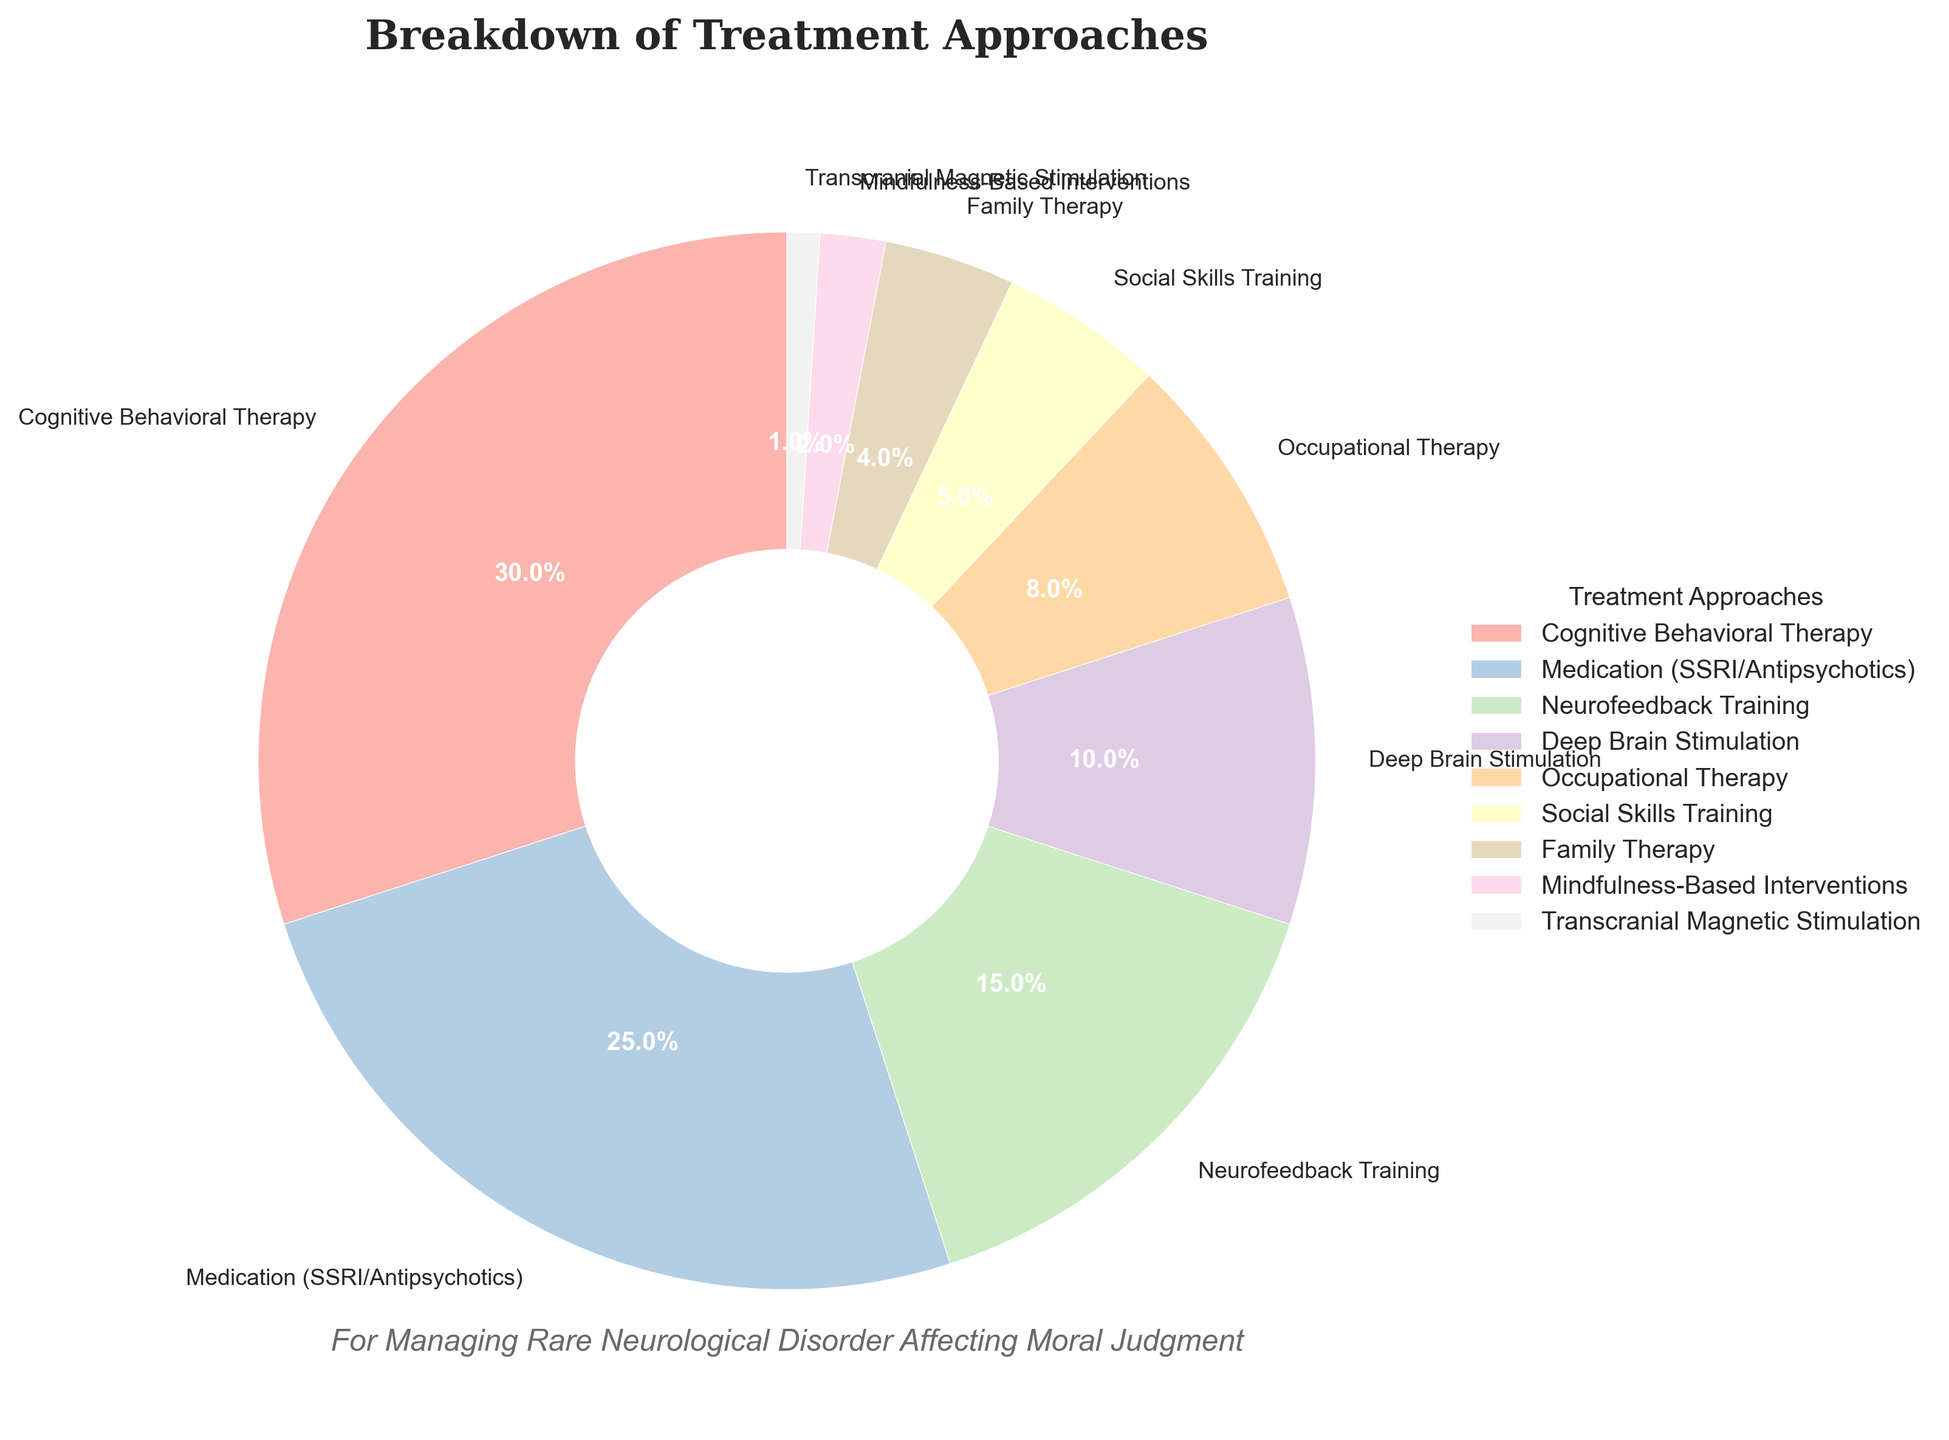What is the largest treatment category? The largest treatment category can be identified by looking at the segment with the largest percentage label on the pie chart. The "Cognitive Behavioral Therapy" segment is labeled with 30%, which is the highest value.
Answer: Cognitive Behavioral Therapy How much greater is the percentage of Cognitive Behavioral Therapy compared to Social Skills Training? First, locate the percentages of both Cognitive Behavioral Therapy and Social Skills Training on the pie chart, which are 30% and 5% respectively. Subtract the smaller percentage from the larger one: 30% - 5% = 25%.
Answer: 25% What are the combined percentages of Family Therapy, Mindfulness-Based Interventions, and Transcranial Magnetic Stimulation? Find the percentages for Family Therapy (4%), Mindfulness-Based Interventions (2%), and Transcranial Magnetic Stimulation (1%). Add these percentages together: 4% + 2% + 1% = 7%.
Answer: 7% Which treatment approach has a smaller percentage, Deep Brain Stimulation or Occupational Therapy? By examining the segments for Deep Brain Stimulation and Occupational Therapy on the pie chart, note their percentages: Deep Brain Stimulation is 10%, whereas Occupational Therapy is 8%. Thus, Occupational Therapy has a smaller percentage.
Answer: Occupational Therapy What treatment approach is represented in the segment that is colored light pink (lightest color in the chart)? Visually identify the segment on the pie chart that has the lightest color, which corresponds to the smallest percentage (1%). This segment represents Transcranial Magnetic Stimulation.
Answer: Transcranial Magnetic Stimulation What is the difference in percentage between Neurofeedback Training and Medication (SSRI/Antipsychotics)? Locate the segments and percentages for Neurofeedback Training and Medication (SSRI/Antipsychotics) on the pie chart, which are 15% and 25%, respectively. Subtract the percentage for Neurofeedback Training from that of Medication: 25% - 15% = 10%.
Answer: 10% What is the total percentage for all non-therapy treatment approaches listed? The non-therapy treatment approaches include Medication (25%), Neurofeedback Training (15%), Deep Brain Stimulation (10%), and Transcranial Magnetic Stimulation (1%). Add these percentages together: 25% + 15% + 10% + 1% = 51%.
Answer: 51% Which treatment approach shares the same color in the legend as Occupational Therapy? Locate the segment for Occupational Therapy on the pie chart and observe its color. Then find the segment in the legend with the same color. These visual attributes show that Occupational Therapy has a unique color with no other segment sharing the same color.
Answer: None 